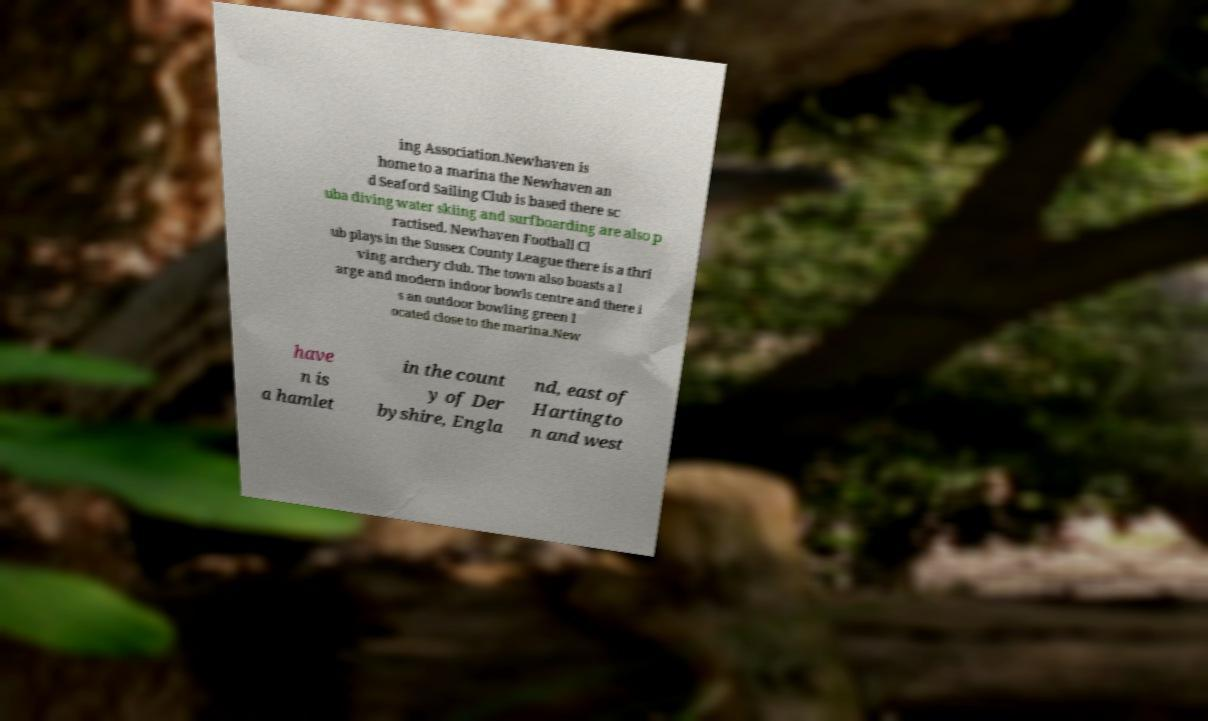I need the written content from this picture converted into text. Can you do that? ing Association.Newhaven is home to a marina the Newhaven an d Seaford Sailing Club is based there sc uba diving water skiing and surfboarding are also p ractised. Newhaven Football Cl ub plays in the Sussex County League there is a thri ving archery club. The town also boasts a l arge and modern indoor bowls centre and there i s an outdoor bowling green l ocated close to the marina.New have n is a hamlet in the count y of Der byshire, Engla nd, east of Hartingto n and west 